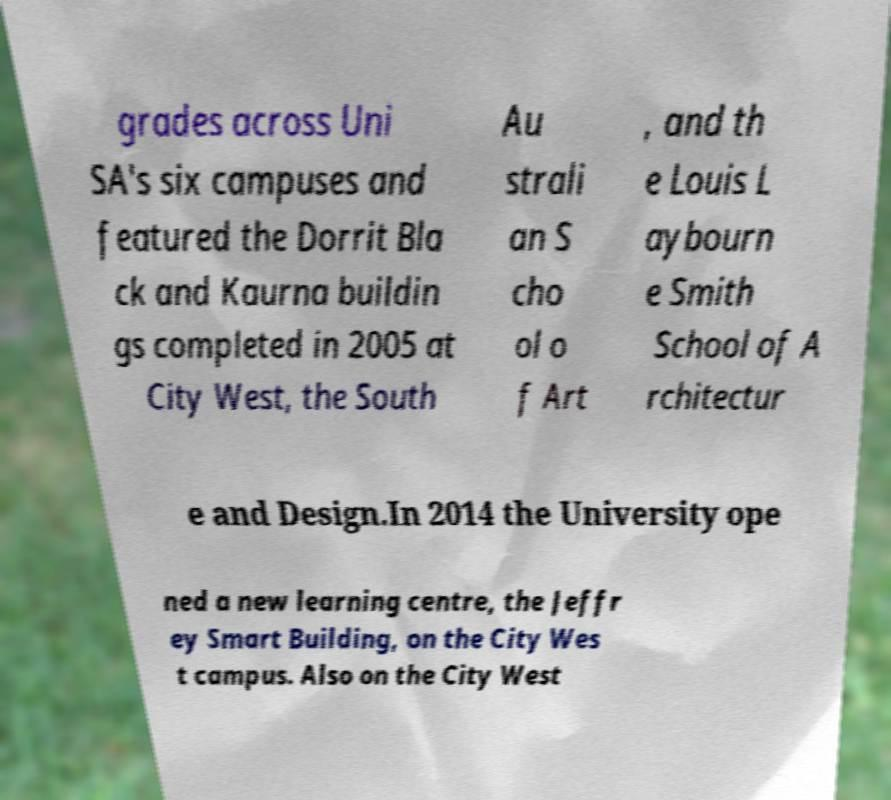There's text embedded in this image that I need extracted. Can you transcribe it verbatim? grades across Uni SA's six campuses and featured the Dorrit Bla ck and Kaurna buildin gs completed in 2005 at City West, the South Au strali an S cho ol o f Art , and th e Louis L aybourn e Smith School of A rchitectur e and Design.In 2014 the University ope ned a new learning centre, the Jeffr ey Smart Building, on the City Wes t campus. Also on the City West 